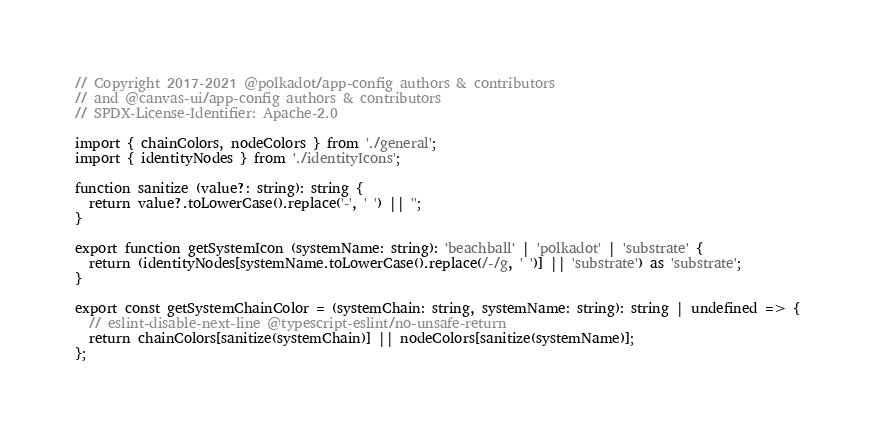<code> <loc_0><loc_0><loc_500><loc_500><_TypeScript_>// Copyright 2017-2021 @polkadot/app-config authors & contributors
// and @canvas-ui/app-config authors & contributors
// SPDX-License-Identifier: Apache-2.0

import { chainColors, nodeColors } from './general';
import { identityNodes } from './identityIcons';

function sanitize (value?: string): string {
  return value?.toLowerCase().replace('-', ' ') || '';
}

export function getSystemIcon (systemName: string): 'beachball' | 'polkadot' | 'substrate' {
  return (identityNodes[systemName.toLowerCase().replace(/-/g, ' ')] || 'substrate') as 'substrate';
}

export const getSystemChainColor = (systemChain: string, systemName: string): string | undefined => {
  // eslint-disable-next-line @typescript-eslint/no-unsafe-return
  return chainColors[sanitize(systemChain)] || nodeColors[sanitize(systemName)];
};
</code> 